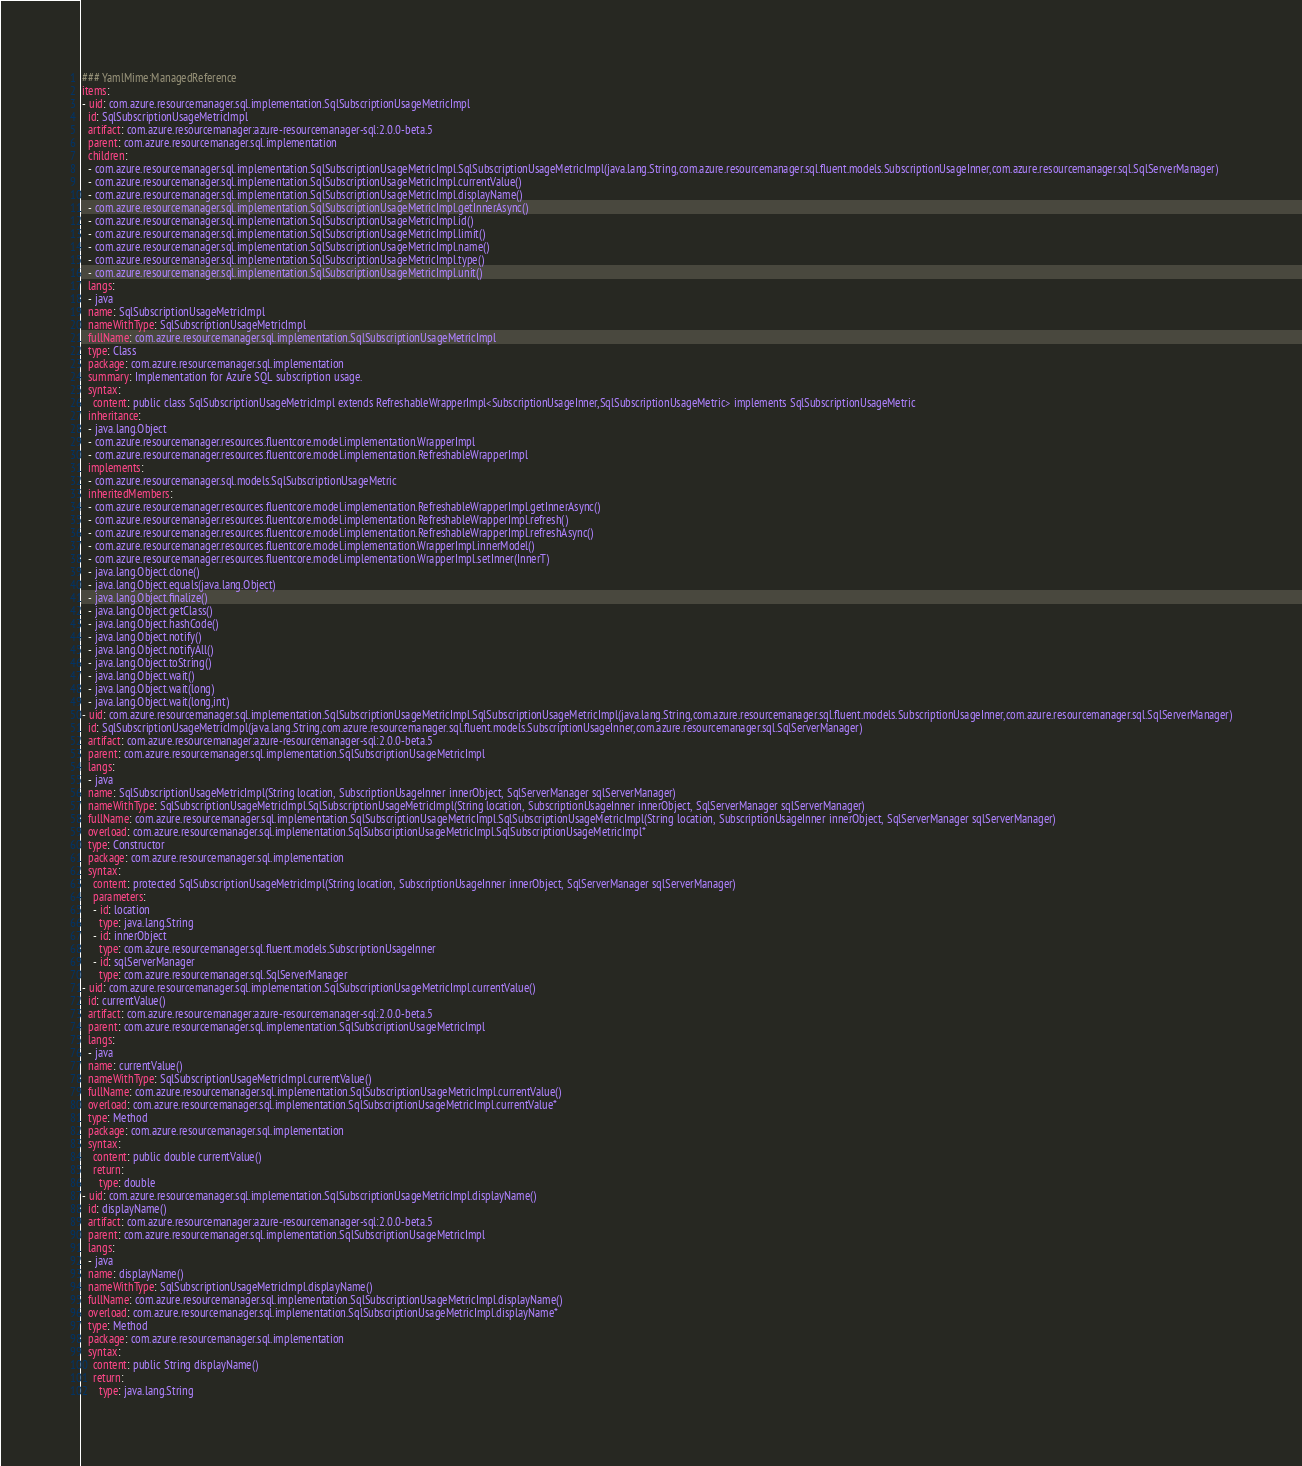<code> <loc_0><loc_0><loc_500><loc_500><_YAML_>### YamlMime:ManagedReference
items:
- uid: com.azure.resourcemanager.sql.implementation.SqlSubscriptionUsageMetricImpl
  id: SqlSubscriptionUsageMetricImpl
  artifact: com.azure.resourcemanager:azure-resourcemanager-sql:2.0.0-beta.5
  parent: com.azure.resourcemanager.sql.implementation
  children:
  - com.azure.resourcemanager.sql.implementation.SqlSubscriptionUsageMetricImpl.SqlSubscriptionUsageMetricImpl(java.lang.String,com.azure.resourcemanager.sql.fluent.models.SubscriptionUsageInner,com.azure.resourcemanager.sql.SqlServerManager)
  - com.azure.resourcemanager.sql.implementation.SqlSubscriptionUsageMetricImpl.currentValue()
  - com.azure.resourcemanager.sql.implementation.SqlSubscriptionUsageMetricImpl.displayName()
  - com.azure.resourcemanager.sql.implementation.SqlSubscriptionUsageMetricImpl.getInnerAsync()
  - com.azure.resourcemanager.sql.implementation.SqlSubscriptionUsageMetricImpl.id()
  - com.azure.resourcemanager.sql.implementation.SqlSubscriptionUsageMetricImpl.limit()
  - com.azure.resourcemanager.sql.implementation.SqlSubscriptionUsageMetricImpl.name()
  - com.azure.resourcemanager.sql.implementation.SqlSubscriptionUsageMetricImpl.type()
  - com.azure.resourcemanager.sql.implementation.SqlSubscriptionUsageMetricImpl.unit()
  langs:
  - java
  name: SqlSubscriptionUsageMetricImpl
  nameWithType: SqlSubscriptionUsageMetricImpl
  fullName: com.azure.resourcemanager.sql.implementation.SqlSubscriptionUsageMetricImpl
  type: Class
  package: com.azure.resourcemanager.sql.implementation
  summary: Implementation for Azure SQL subscription usage.
  syntax:
    content: public class SqlSubscriptionUsageMetricImpl extends RefreshableWrapperImpl<SubscriptionUsageInner,SqlSubscriptionUsageMetric> implements SqlSubscriptionUsageMetric
  inheritance:
  - java.lang.Object
  - com.azure.resourcemanager.resources.fluentcore.model.implementation.WrapperImpl
  - com.azure.resourcemanager.resources.fluentcore.model.implementation.RefreshableWrapperImpl
  implements:
  - com.azure.resourcemanager.sql.models.SqlSubscriptionUsageMetric
  inheritedMembers:
  - com.azure.resourcemanager.resources.fluentcore.model.implementation.RefreshableWrapperImpl.getInnerAsync()
  - com.azure.resourcemanager.resources.fluentcore.model.implementation.RefreshableWrapperImpl.refresh()
  - com.azure.resourcemanager.resources.fluentcore.model.implementation.RefreshableWrapperImpl.refreshAsync()
  - com.azure.resourcemanager.resources.fluentcore.model.implementation.WrapperImpl.innerModel()
  - com.azure.resourcemanager.resources.fluentcore.model.implementation.WrapperImpl.setInner(InnerT)
  - java.lang.Object.clone()
  - java.lang.Object.equals(java.lang.Object)
  - java.lang.Object.finalize()
  - java.lang.Object.getClass()
  - java.lang.Object.hashCode()
  - java.lang.Object.notify()
  - java.lang.Object.notifyAll()
  - java.lang.Object.toString()
  - java.lang.Object.wait()
  - java.lang.Object.wait(long)
  - java.lang.Object.wait(long,int)
- uid: com.azure.resourcemanager.sql.implementation.SqlSubscriptionUsageMetricImpl.SqlSubscriptionUsageMetricImpl(java.lang.String,com.azure.resourcemanager.sql.fluent.models.SubscriptionUsageInner,com.azure.resourcemanager.sql.SqlServerManager)
  id: SqlSubscriptionUsageMetricImpl(java.lang.String,com.azure.resourcemanager.sql.fluent.models.SubscriptionUsageInner,com.azure.resourcemanager.sql.SqlServerManager)
  artifact: com.azure.resourcemanager:azure-resourcemanager-sql:2.0.0-beta.5
  parent: com.azure.resourcemanager.sql.implementation.SqlSubscriptionUsageMetricImpl
  langs:
  - java
  name: SqlSubscriptionUsageMetricImpl(String location, SubscriptionUsageInner innerObject, SqlServerManager sqlServerManager)
  nameWithType: SqlSubscriptionUsageMetricImpl.SqlSubscriptionUsageMetricImpl(String location, SubscriptionUsageInner innerObject, SqlServerManager sqlServerManager)
  fullName: com.azure.resourcemanager.sql.implementation.SqlSubscriptionUsageMetricImpl.SqlSubscriptionUsageMetricImpl(String location, SubscriptionUsageInner innerObject, SqlServerManager sqlServerManager)
  overload: com.azure.resourcemanager.sql.implementation.SqlSubscriptionUsageMetricImpl.SqlSubscriptionUsageMetricImpl*
  type: Constructor
  package: com.azure.resourcemanager.sql.implementation
  syntax:
    content: protected SqlSubscriptionUsageMetricImpl(String location, SubscriptionUsageInner innerObject, SqlServerManager sqlServerManager)
    parameters:
    - id: location
      type: java.lang.String
    - id: innerObject
      type: com.azure.resourcemanager.sql.fluent.models.SubscriptionUsageInner
    - id: sqlServerManager
      type: com.azure.resourcemanager.sql.SqlServerManager
- uid: com.azure.resourcemanager.sql.implementation.SqlSubscriptionUsageMetricImpl.currentValue()
  id: currentValue()
  artifact: com.azure.resourcemanager:azure-resourcemanager-sql:2.0.0-beta.5
  parent: com.azure.resourcemanager.sql.implementation.SqlSubscriptionUsageMetricImpl
  langs:
  - java
  name: currentValue()
  nameWithType: SqlSubscriptionUsageMetricImpl.currentValue()
  fullName: com.azure.resourcemanager.sql.implementation.SqlSubscriptionUsageMetricImpl.currentValue()
  overload: com.azure.resourcemanager.sql.implementation.SqlSubscriptionUsageMetricImpl.currentValue*
  type: Method
  package: com.azure.resourcemanager.sql.implementation
  syntax:
    content: public double currentValue()
    return:
      type: double
- uid: com.azure.resourcemanager.sql.implementation.SqlSubscriptionUsageMetricImpl.displayName()
  id: displayName()
  artifact: com.azure.resourcemanager:azure-resourcemanager-sql:2.0.0-beta.5
  parent: com.azure.resourcemanager.sql.implementation.SqlSubscriptionUsageMetricImpl
  langs:
  - java
  name: displayName()
  nameWithType: SqlSubscriptionUsageMetricImpl.displayName()
  fullName: com.azure.resourcemanager.sql.implementation.SqlSubscriptionUsageMetricImpl.displayName()
  overload: com.azure.resourcemanager.sql.implementation.SqlSubscriptionUsageMetricImpl.displayName*
  type: Method
  package: com.azure.resourcemanager.sql.implementation
  syntax:
    content: public String displayName()
    return:
      type: java.lang.String</code> 